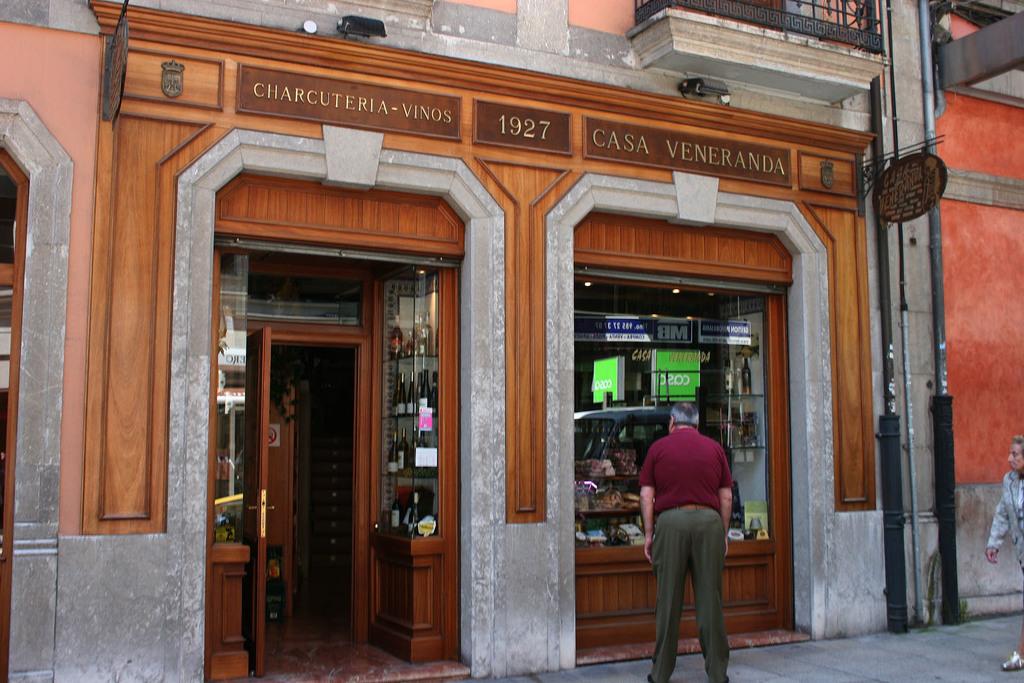What is the year on the business sign?
Give a very brief answer. 1927. What is written on the sign above the window on the right?
Offer a terse response. Casa veneranda. 